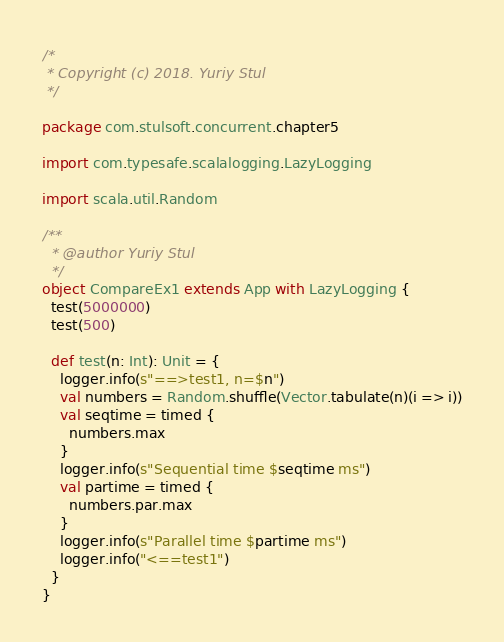Convert code to text. <code><loc_0><loc_0><loc_500><loc_500><_Scala_>/*
 * Copyright (c) 2018. Yuriy Stul
 */

package com.stulsoft.concurrent.chapter5

import com.typesafe.scalalogging.LazyLogging

import scala.util.Random

/**
  * @author Yuriy Stul
  */
object CompareEx1 extends App with LazyLogging {
  test(5000000)
  test(500)

  def test(n: Int): Unit = {
    logger.info(s"==>test1, n=$n")
    val numbers = Random.shuffle(Vector.tabulate(n)(i => i))
    val seqtime = timed {
      numbers.max
    }
    logger.info(s"Sequential time $seqtime ms")
    val partime = timed {
      numbers.par.max
    }
    logger.info(s"Parallel time $partime ms")
    logger.info("<==test1")
  }
}
</code> 